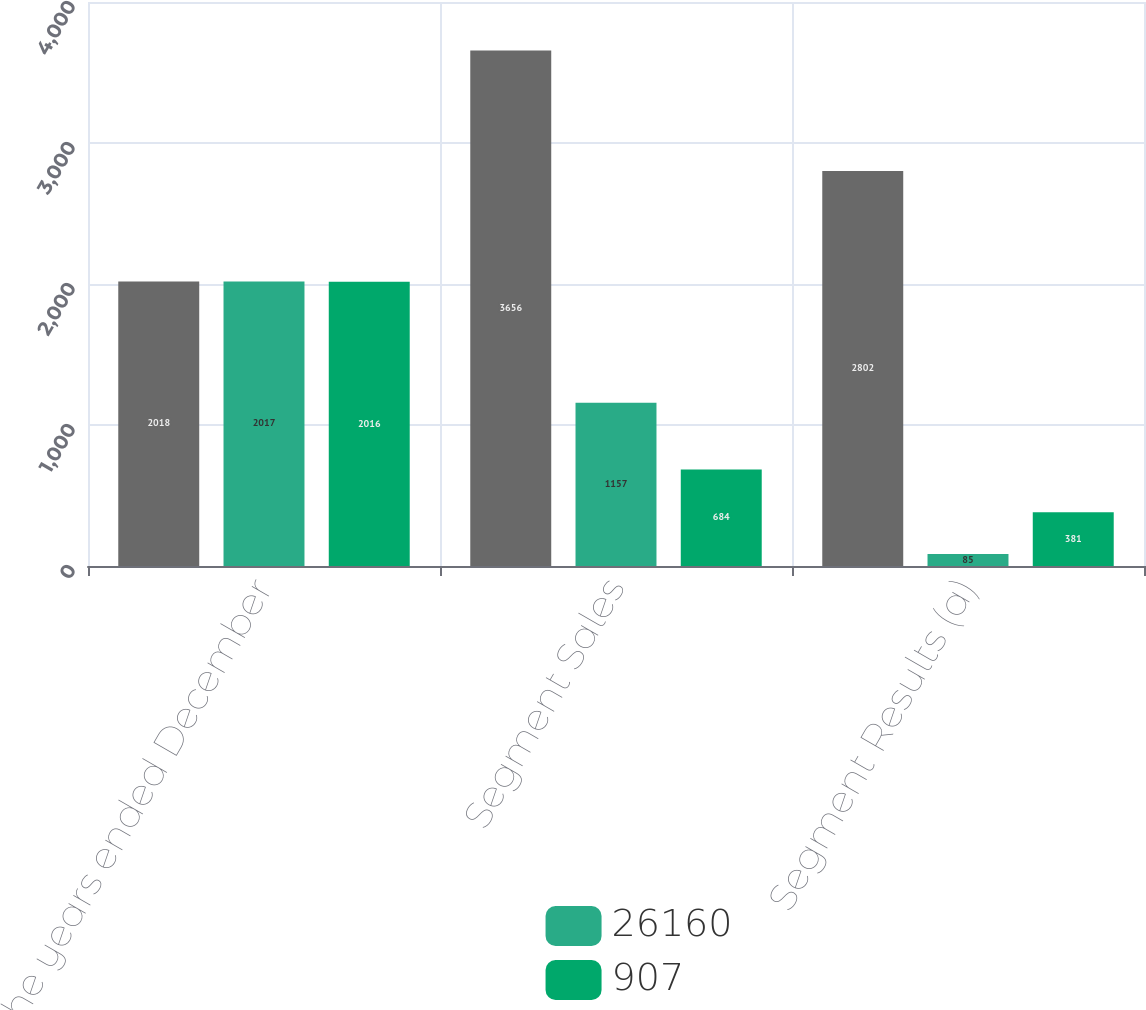Convert chart to OTSL. <chart><loc_0><loc_0><loc_500><loc_500><stacked_bar_chart><ecel><fcel>For the years ended December<fcel>Segment Sales<fcel>Segment Results (a)<nl><fcel>nan<fcel>2018<fcel>3656<fcel>2802<nl><fcel>26160<fcel>2017<fcel>1157<fcel>85<nl><fcel>907<fcel>2016<fcel>684<fcel>381<nl></chart> 